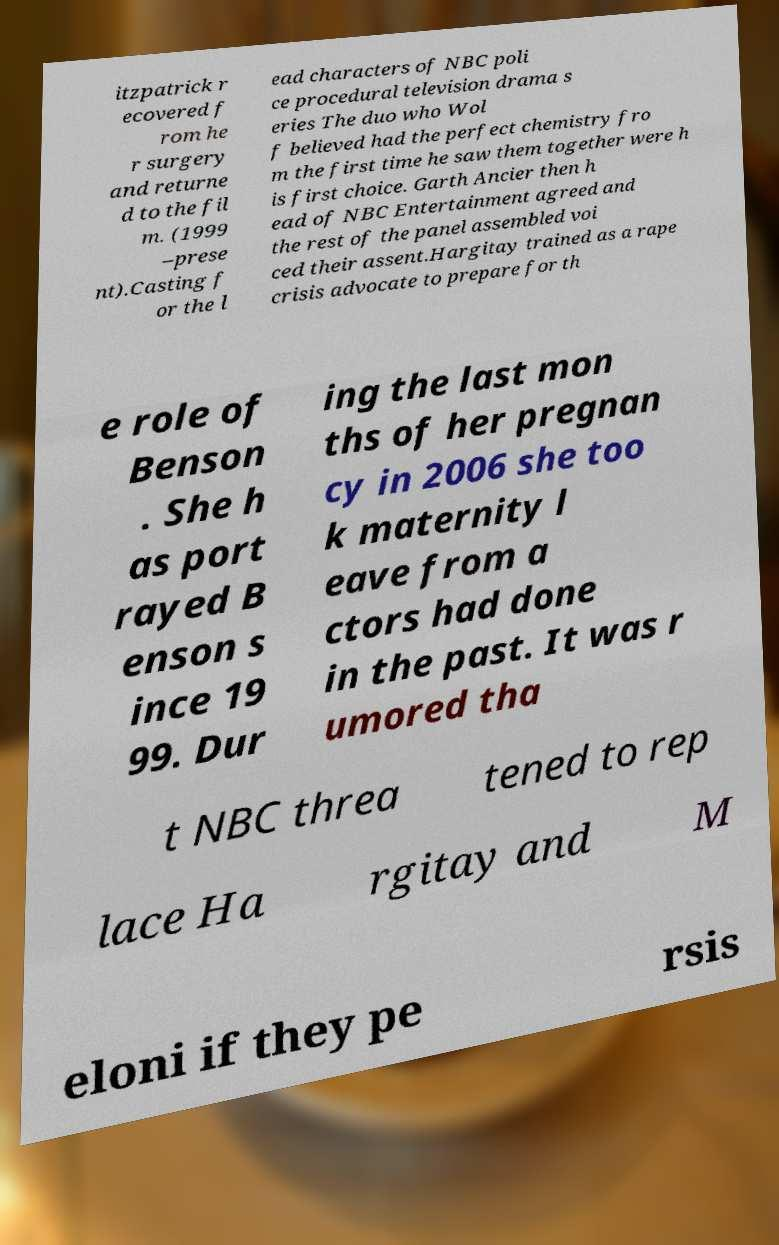Can you read and provide the text displayed in the image?This photo seems to have some interesting text. Can you extract and type it out for me? itzpatrick r ecovered f rom he r surgery and returne d to the fil m. (1999 –prese nt).Casting f or the l ead characters of NBC poli ce procedural television drama s eries The duo who Wol f believed had the perfect chemistry fro m the first time he saw them together were h is first choice. Garth Ancier then h ead of NBC Entertainment agreed and the rest of the panel assembled voi ced their assent.Hargitay trained as a rape crisis advocate to prepare for th e role of Benson . She h as port rayed B enson s ince 19 99. Dur ing the last mon ths of her pregnan cy in 2006 she too k maternity l eave from a ctors had done in the past. It was r umored tha t NBC threa tened to rep lace Ha rgitay and M eloni if they pe rsis 